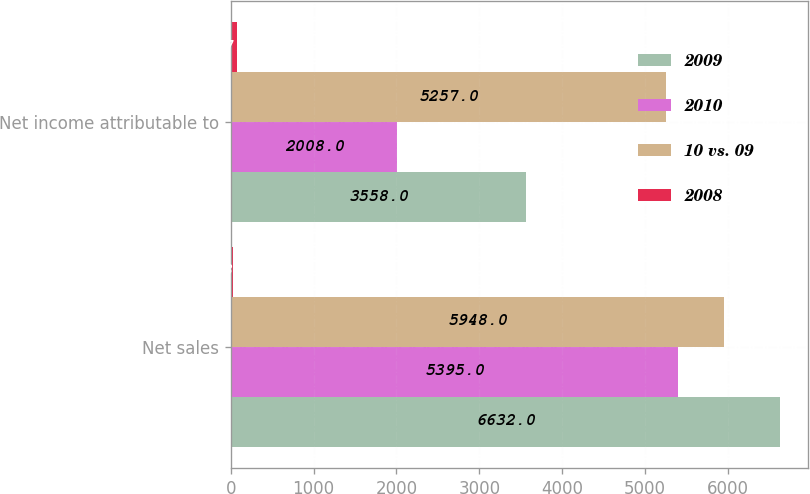Convert chart. <chart><loc_0><loc_0><loc_500><loc_500><stacked_bar_chart><ecel><fcel>Net sales<fcel>Net income attributable to<nl><fcel>2009<fcel>6632<fcel>3558<nl><fcel>2010<fcel>5395<fcel>2008<nl><fcel>10 vs. 09<fcel>5948<fcel>5257<nl><fcel>2008<fcel>23<fcel>77<nl></chart> 